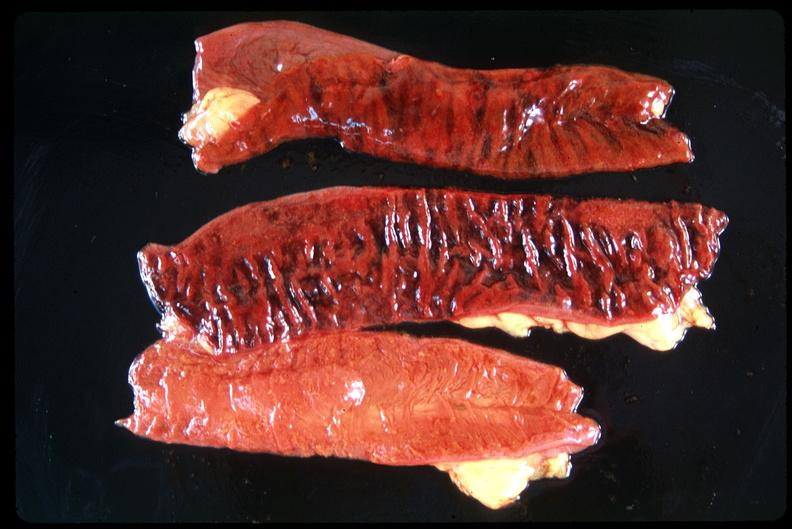what does this image show?
Answer the question using a single word or phrase. Small intestine 